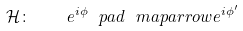<formula> <loc_0><loc_0><loc_500><loc_500>\mathcal { H } \colon \quad e ^ { i \phi } \ p a d { \ m a p a r r o w } e ^ { i \phi ^ { \prime } }</formula> 